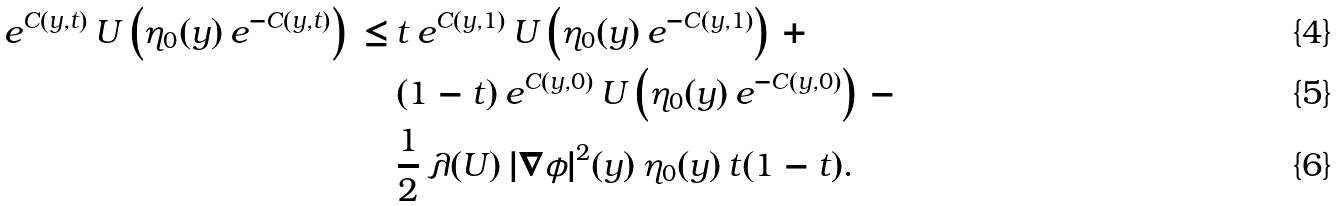Convert formula to latex. <formula><loc_0><loc_0><loc_500><loc_500>e ^ { C ( y , t ) } \, U \left ( \eta _ { 0 } ( y ) \, e ^ { - C ( y , t ) } \right ) \, \leq \, & t \, e ^ { C ( y , 1 ) } \, U \left ( \eta _ { 0 } ( y ) \, e ^ { - C ( y , 1 ) } \right ) \, + \\ & ( 1 - t ) \, e ^ { C ( y , 0 ) } \, U \left ( \eta _ { 0 } ( y ) \, e ^ { - C ( y , 0 ) } \right ) \, - \\ & \frac { 1 } { 2 } \, \lambda ( U ) \, | \nabla \phi | ^ { 2 } ( y ) \, \eta _ { 0 } ( y ) \, t ( 1 - t ) .</formula> 